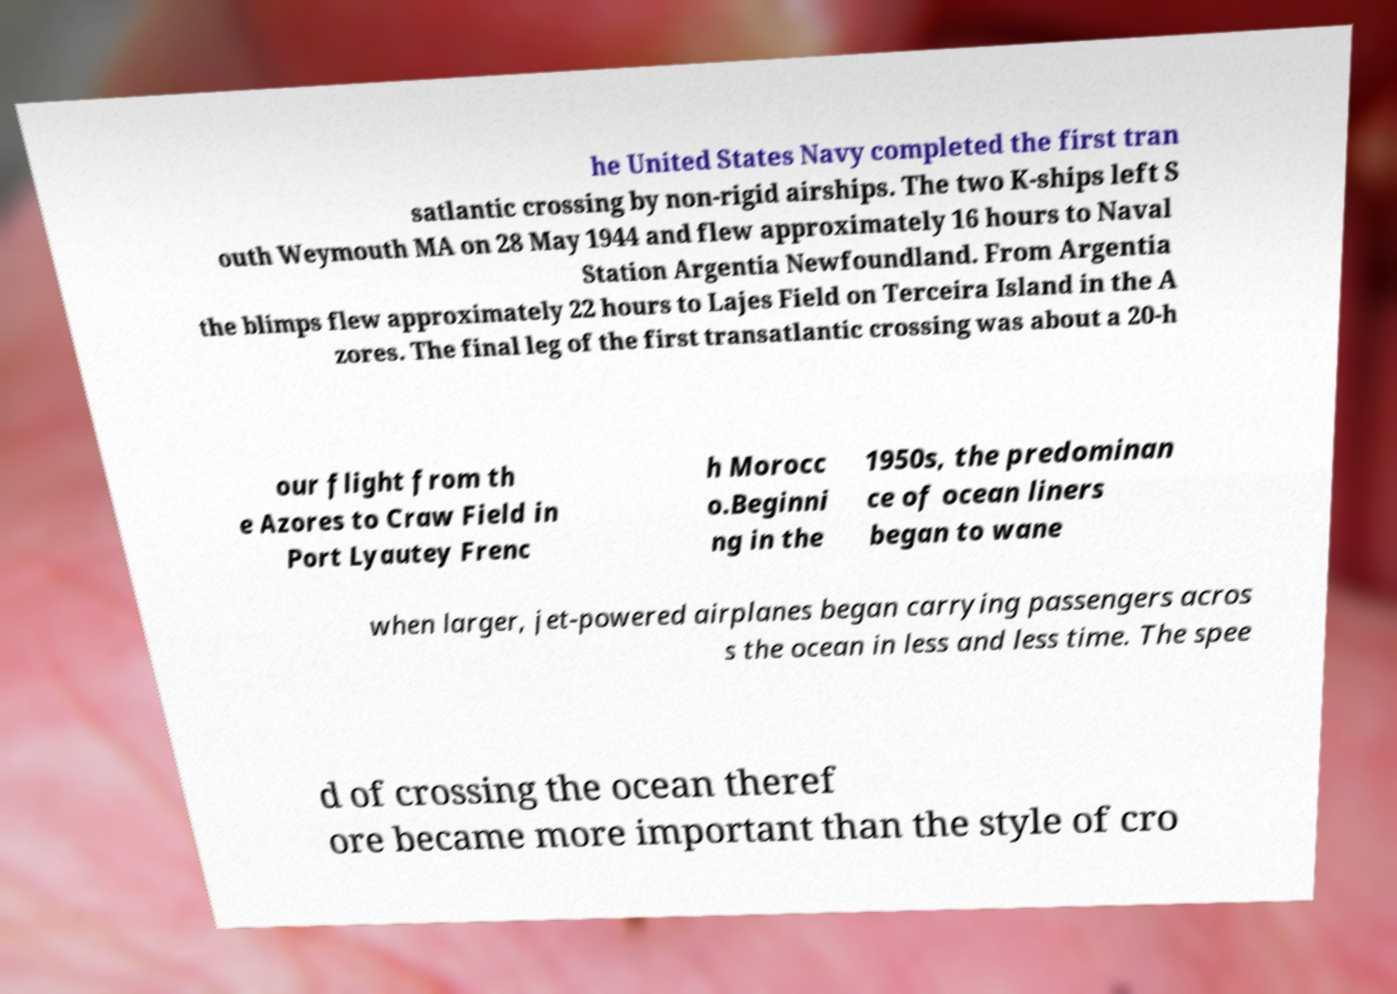Please identify and transcribe the text found in this image. he United States Navy completed the first tran satlantic crossing by non-rigid airships. The two K-ships left S outh Weymouth MA on 28 May 1944 and flew approximately 16 hours to Naval Station Argentia Newfoundland. From Argentia the blimps flew approximately 22 hours to Lajes Field on Terceira Island in the A zores. The final leg of the first transatlantic crossing was about a 20-h our flight from th e Azores to Craw Field in Port Lyautey Frenc h Morocc o.Beginni ng in the 1950s, the predominan ce of ocean liners began to wane when larger, jet-powered airplanes began carrying passengers acros s the ocean in less and less time. The spee d of crossing the ocean theref ore became more important than the style of cro 